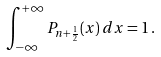Convert formula to latex. <formula><loc_0><loc_0><loc_500><loc_500>\int _ { - \infty } ^ { + \infty } P _ { n + \frac { 1 } { 2 } } ( x ) \, d x = 1 \, .</formula> 